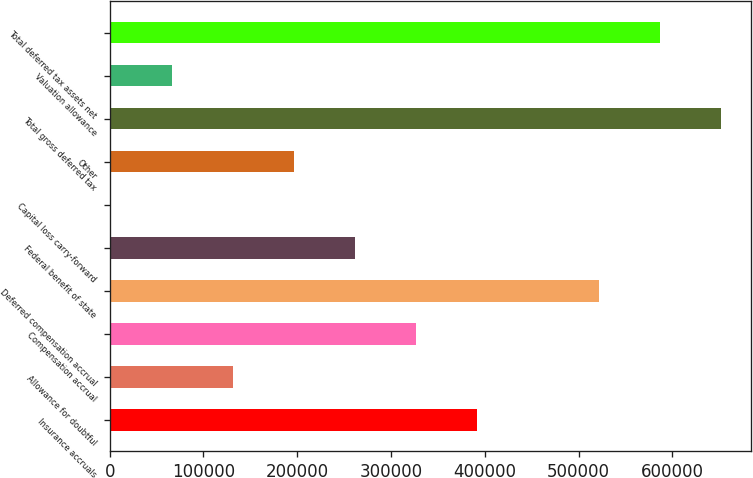Convert chart to OTSL. <chart><loc_0><loc_0><loc_500><loc_500><bar_chart><fcel>Insurance accruals<fcel>Allowance for doubtful<fcel>Compensation accrual<fcel>Deferred compensation accrual<fcel>Federal benefit of state<fcel>Capital loss carry-forward<fcel>Other<fcel>Total gross deferred tax<fcel>Valuation allowance<fcel>Total deferred tax assets net<nl><fcel>391645<fcel>131510<fcel>326612<fcel>521713<fcel>261578<fcel>1443<fcel>196544<fcel>651780<fcel>66476.7<fcel>586746<nl></chart> 